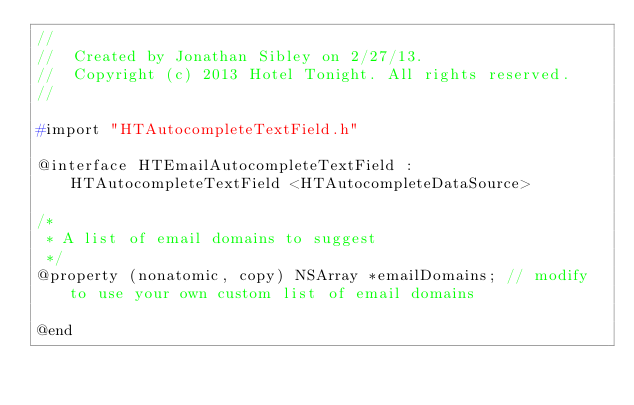<code> <loc_0><loc_0><loc_500><loc_500><_C_>//
//  Created by Jonathan Sibley on 2/27/13.
//  Copyright (c) 2013 Hotel Tonight. All rights reserved.
//

#import "HTAutocompleteTextField.h"

@interface HTEmailAutocompleteTextField : HTAutocompleteTextField <HTAutocompleteDataSource>

/*
 * A list of email domains to suggest
 */
@property (nonatomic, copy) NSArray *emailDomains; // modify to use your own custom list of email domains

@end
</code> 